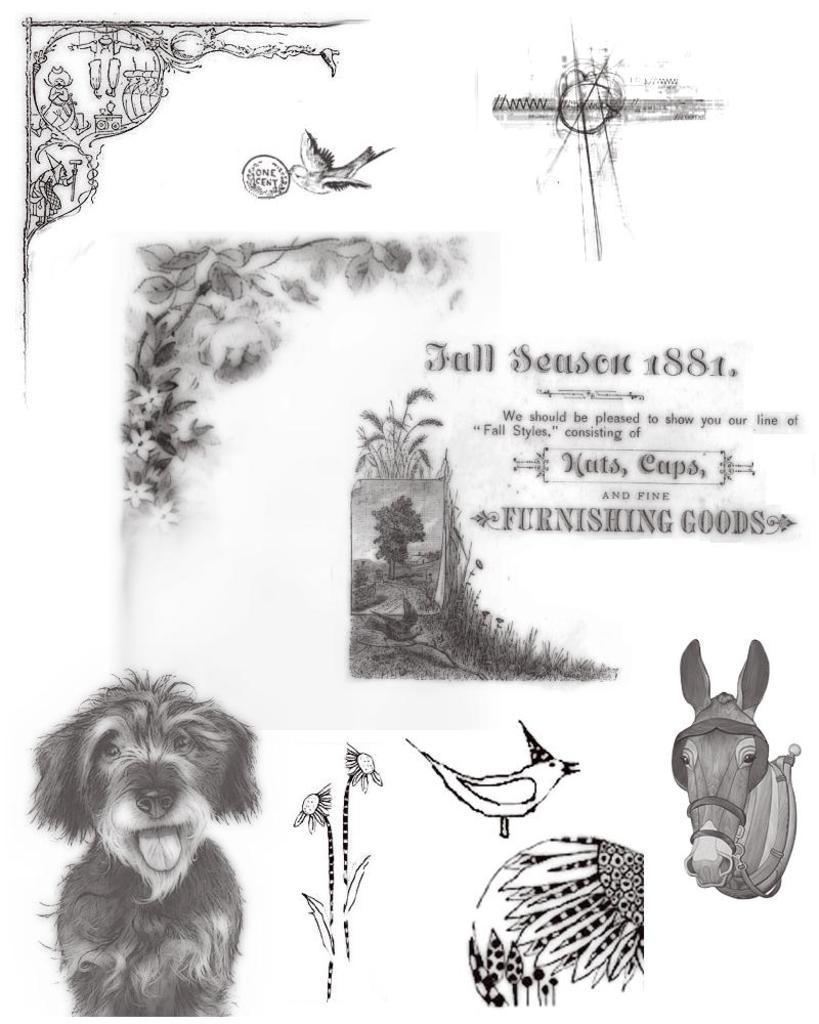Can you describe this image briefly? In the image we can see a paper, in the paper we can see drawings and text. 